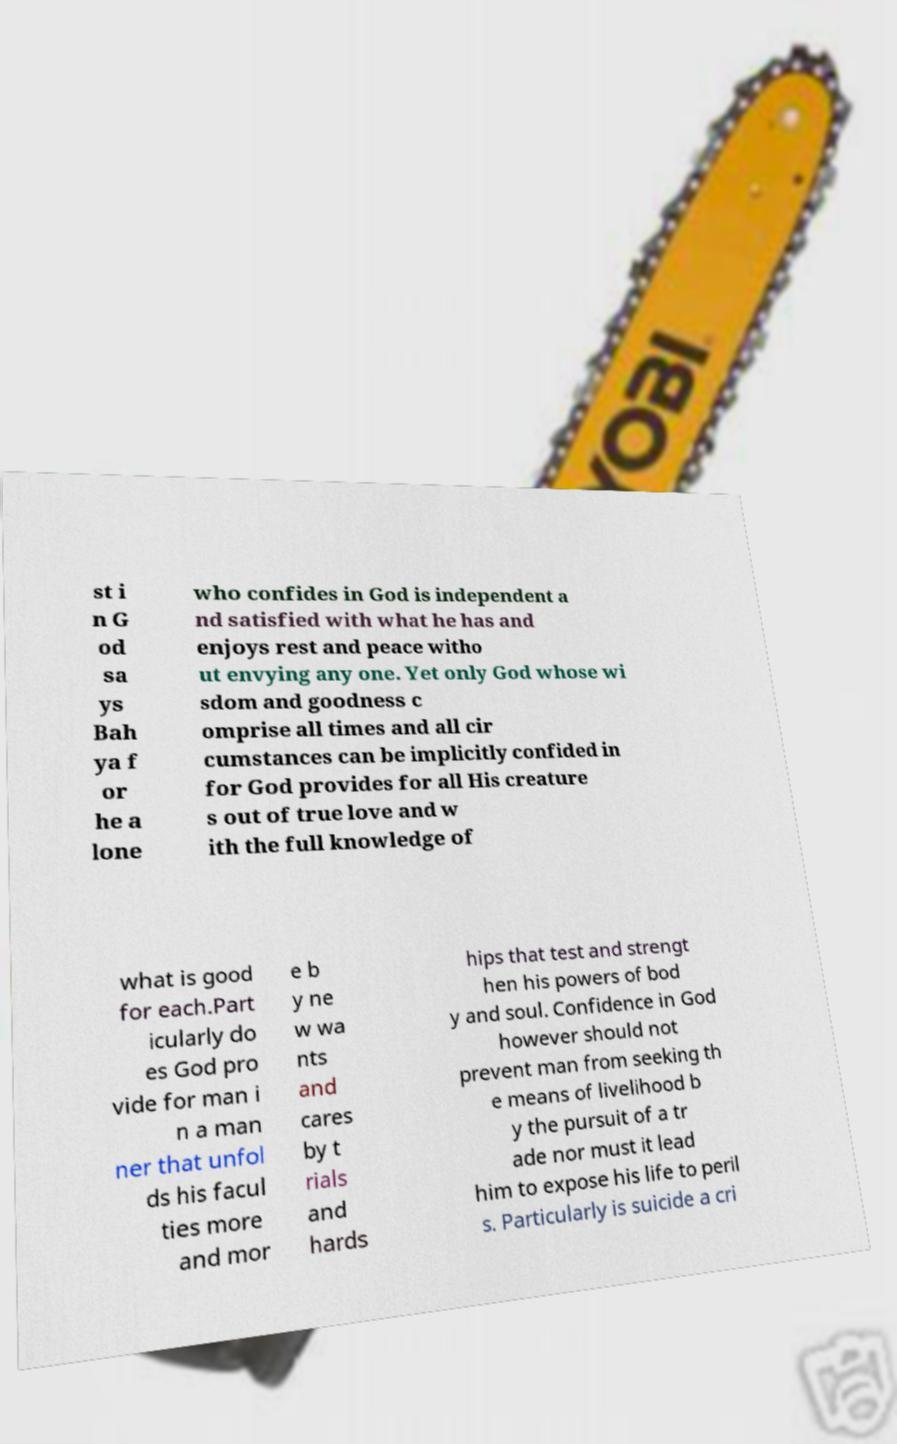Please identify and transcribe the text found in this image. st i n G od sa ys Bah ya f or he a lone who confides in God is independent a nd satisfied with what he has and enjoys rest and peace witho ut envying any one. Yet only God whose wi sdom and goodness c omprise all times and all cir cumstances can be implicitly confided in for God provides for all His creature s out of true love and w ith the full knowledge of what is good for each.Part icularly do es God pro vide for man i n a man ner that unfol ds his facul ties more and mor e b y ne w wa nts and cares by t rials and hards hips that test and strengt hen his powers of bod y and soul. Confidence in God however should not prevent man from seeking th e means of livelihood b y the pursuit of a tr ade nor must it lead him to expose his life to peril s. Particularly is suicide a cri 